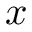Convert formula to latex. <formula><loc_0><loc_0><loc_500><loc_500>x</formula> 